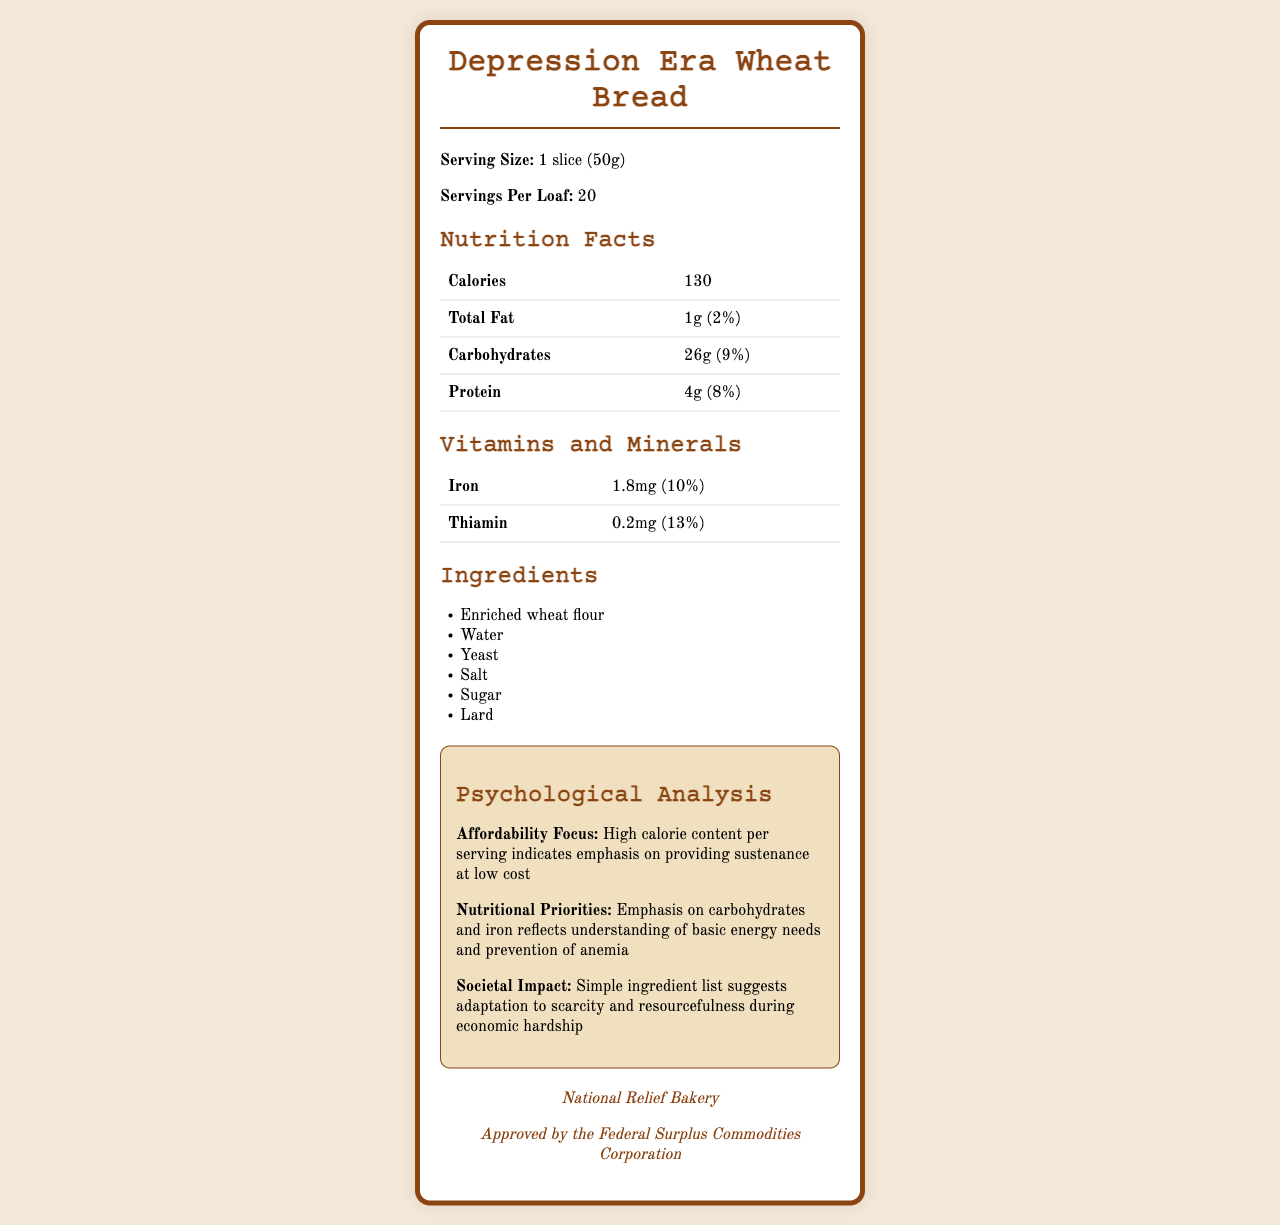what is the serving size? The serving size is explicitly listed as "1 slice (50g)".
Answer: 1 slice (50g) how many calories are in a serving? The calories per serving are specified as 130 on the Nutrition Facts table.
Answer: 130 what is the percentage daily value of total fat per serving? The percentage daily value for total fat is indicated as 2%.
Answer: 2% what are the main ingredients in the bread? These ingredients are listed under the Ingredients section.
Answer: Enriched wheat flour, Water, Yeast, Salt, Sugar, Lard what is the daily value percentage of Iron per serving? The daily value percentage for Iron is given as 10%.
Answer: 10% how many servings are there per loaf? The servings per loaf are mentioned as 20.
Answer: 20 what is the amount of protein per serving? The amount of protein per serving is listed as 4g.
Answer: 4g what era does this nutrition label represent? A. Post-WWII B. Great Depression C. Modern Day D. 1960s The historical context mentions that the economic situation is the Great Depression era (1930s).
Answer: B which vitamin or mineral has the highest daily value percentage? A. Iron B. Thiamin C. Calcium D. Vitamin C Thiamin has a daily value percentage of 13%, which is higher than Iron's 10%. Calcium and Vitamin C are not mentioned.
Answer: B is the bread classified for family use during difficult times? Yes/No The consumer guidance section mentions that the bread is suitable for families struggling during difficult times.
Answer: Yes what is the psychological importance of the bread's ingredients list? The psychological analysis section explains that the simple ingredient list indicates resourcefulness during economic hardship.
Answer: Simple ingredient list suggests adaptation to scarcity and resourcefulness during economic hardship summarize the main idea of the document. The document details the nutrition facts, ingredients, psychological analysis, and historical context of a wheat bread product from the Great Depression, highlighting its affordability and nutritional sufficiency for struggling families during the era.
Answer: Depression Era Wheat Bread's Nutrition Facts Label shows an emphasis on providing affordable, high-calorie sustenance during the Great Depression with a focus on basic nutrients and simplicity in ingredients. how does this bread address the nutritional needs of the time period? The psychological analysis mentions the focus on carbohydrates and iron to address basic energy needs and anemia prevention during the Great Depression.
Answer: Emphasizes carbohydrates and iron to meet basic energy needs and prevent anemia what was the role of the Federal Surplus Commodities Corporation? The document references the Federal Surplus Commodities Corporation but does not explain its role.
Answer: Cannot be determined 